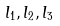Convert formula to latex. <formula><loc_0><loc_0><loc_500><loc_500>l _ { 1 } , l _ { 2 } , l _ { 3 }</formula> 